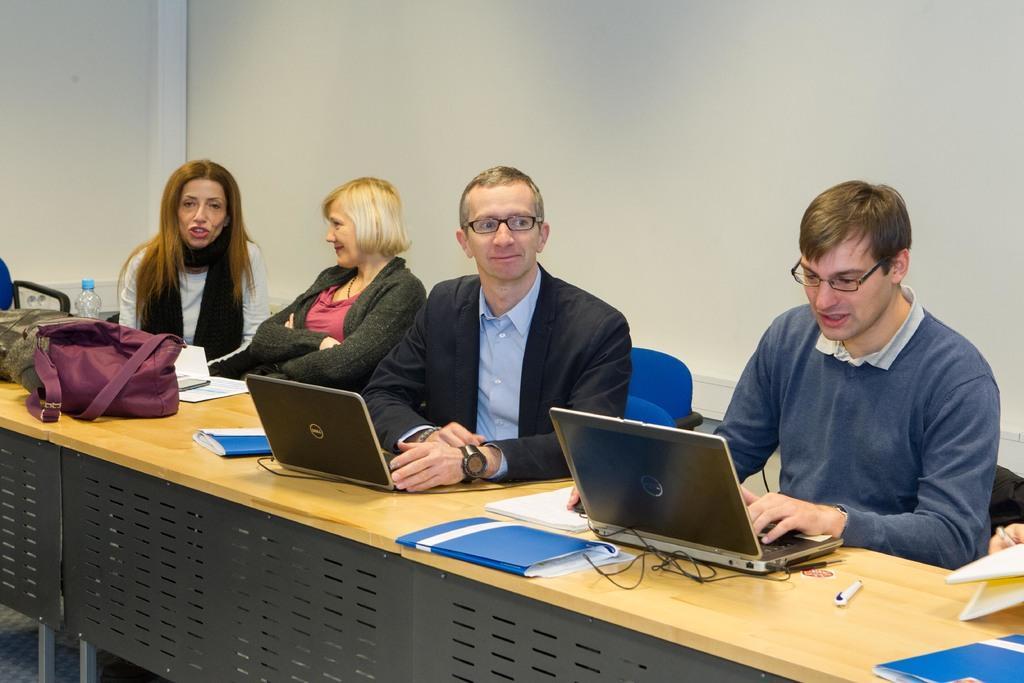Could you give a brief overview of what you see in this image? There are four person. And in front of them there is a table. On the table there are laptops , files and bag , bottles. And a lady wearing a black scarf is talking. In the background there is a wall. And a person wearing a black coat is wearing a watch and spectacles. 